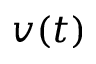Convert formula to latex. <formula><loc_0><loc_0><loc_500><loc_500>v ( t )</formula> 